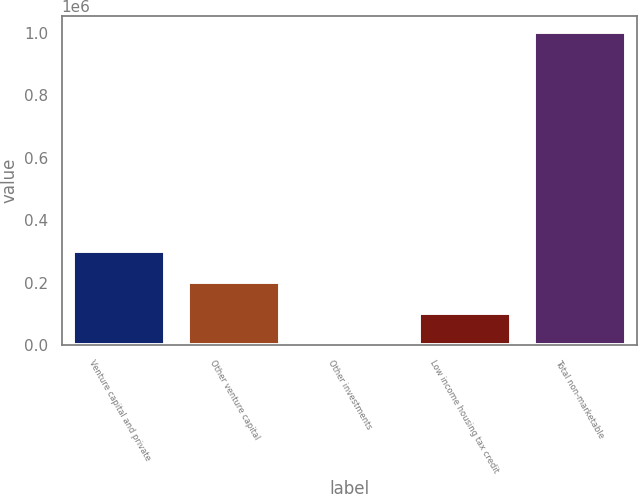Convert chart. <chart><loc_0><loc_0><loc_500><loc_500><bar_chart><fcel>Venture capital and private<fcel>Other venture capital<fcel>Other investments<fcel>Low income housing tax credit<fcel>Total non-marketable<nl><fcel>302023<fcel>201678<fcel>987<fcel>101332<fcel>1.00444e+06<nl></chart> 